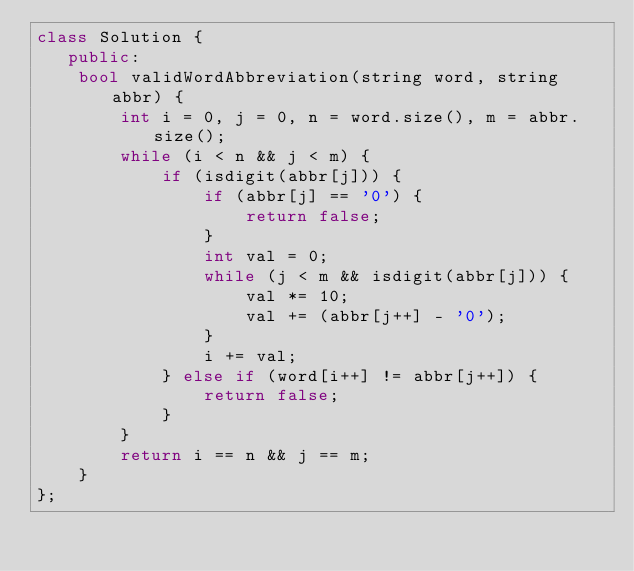Convert code to text. <code><loc_0><loc_0><loc_500><loc_500><_C++_>class Solution {
   public:
    bool validWordAbbreviation(string word, string abbr) {
        int i = 0, j = 0, n = word.size(), m = abbr.size();
        while (i < n && j < m) {
            if (isdigit(abbr[j])) {
                if (abbr[j] == '0') {
                    return false;
                }
                int val = 0;
                while (j < m && isdigit(abbr[j])) {
                    val *= 10;
                    val += (abbr[j++] - '0');
                }
                i += val;
            } else if (word[i++] != abbr[j++]) {
                return false;
            }
        }
        return i == n && j == m;
    }
};</code> 